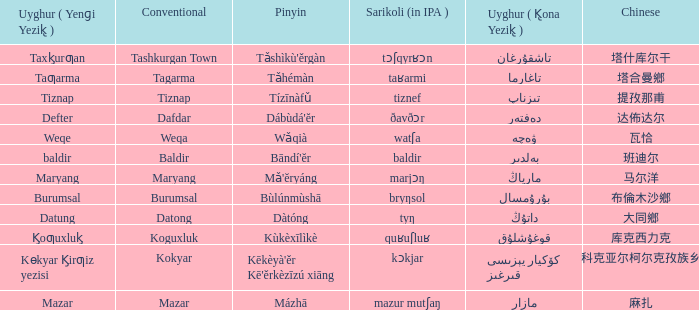Name the uyghur for  瓦恰 ۋەچە. 